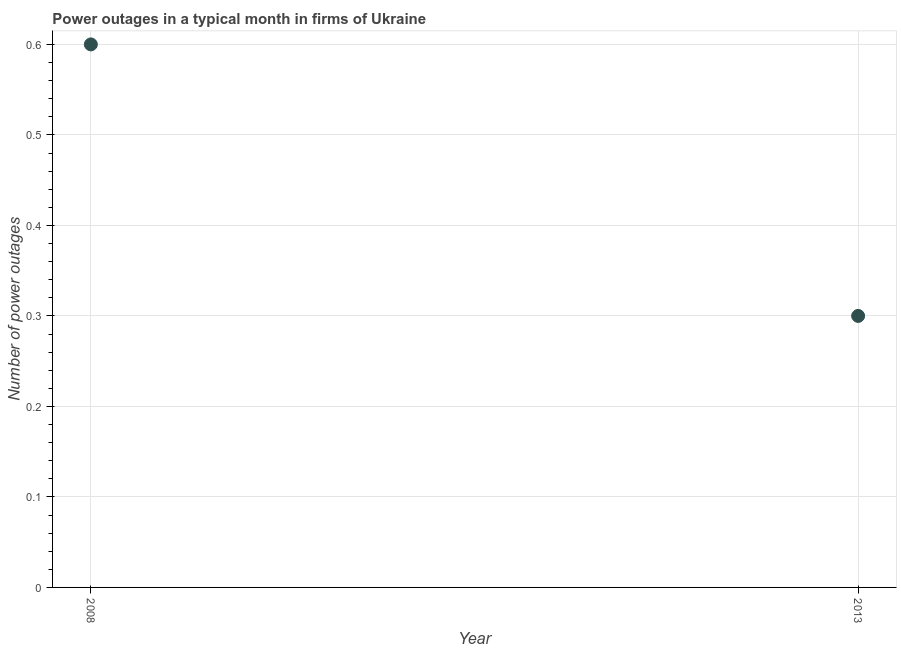In which year was the number of power outages maximum?
Keep it short and to the point. 2008. What is the sum of the number of power outages?
Ensure brevity in your answer.  0.9. What is the difference between the number of power outages in 2008 and 2013?
Keep it short and to the point. 0.3. What is the average number of power outages per year?
Make the answer very short. 0.45. What is the median number of power outages?
Your response must be concise. 0.45. Do a majority of the years between 2013 and 2008 (inclusive) have number of power outages greater than 0.46 ?
Your response must be concise. No. In how many years, is the number of power outages greater than the average number of power outages taken over all years?
Provide a succinct answer. 1. How many dotlines are there?
Give a very brief answer. 1. How many years are there in the graph?
Your answer should be very brief. 2. What is the difference between two consecutive major ticks on the Y-axis?
Ensure brevity in your answer.  0.1. Are the values on the major ticks of Y-axis written in scientific E-notation?
Provide a short and direct response. No. What is the title of the graph?
Provide a short and direct response. Power outages in a typical month in firms of Ukraine. What is the label or title of the Y-axis?
Offer a terse response. Number of power outages. What is the difference between the Number of power outages in 2008 and 2013?
Provide a short and direct response. 0.3. What is the ratio of the Number of power outages in 2008 to that in 2013?
Offer a terse response. 2. 